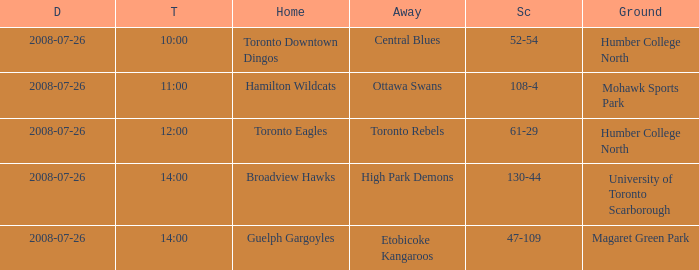When did the High Park Demons play Away? 2008-07-26. 